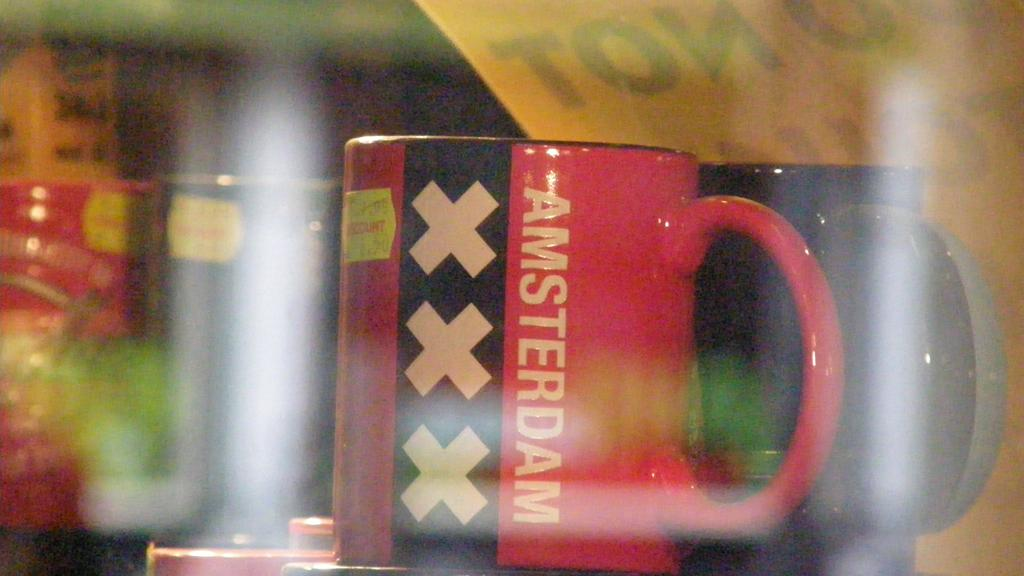Provide a one-sentence caption for the provided image. Two coffee mugs one of them red with three X's on it and the word AMSTERDAM. 